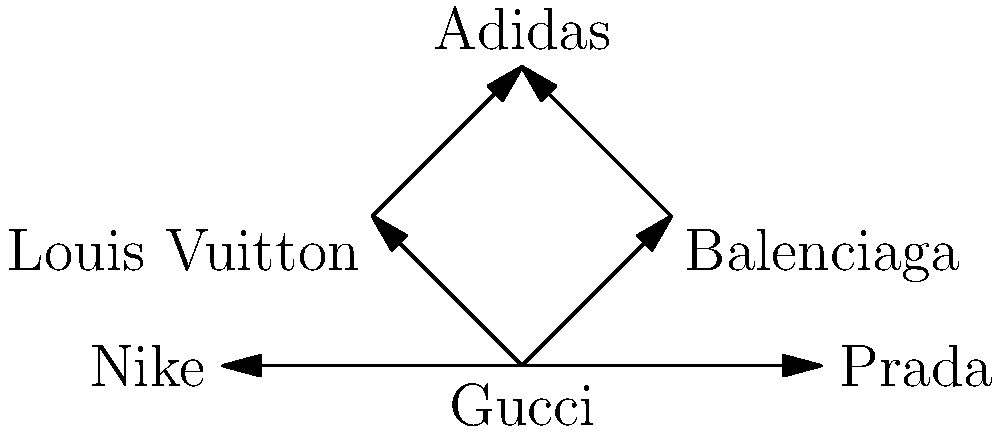In this fashion brand collaboration network, which brand has the highest number of direct collaborations? To determine which brand has the highest number of direct collaborations, we need to count the number of edges (arrows) connected to each vertex (brand) in the network diagram:

1. Gucci: 4 edges (connected to Balenciaga, Louis Vuitton, Nike, and Prada)
2. Balenciaga: 2 edges (connected to Gucci and Adidas)
3. Louis Vuitton: 2 edges (connected to Gucci and Adidas)
4. Adidas: 2 edges (connected to Balenciaga and Louis Vuitton)
5. Nike: 1 edge (connected to Gucci)
6. Prada: 1 edge (connected to Gucci)

Counting the edges for each brand, we can see that Gucci has the highest number of direct collaborations with 4 connections.
Answer: Gucci 